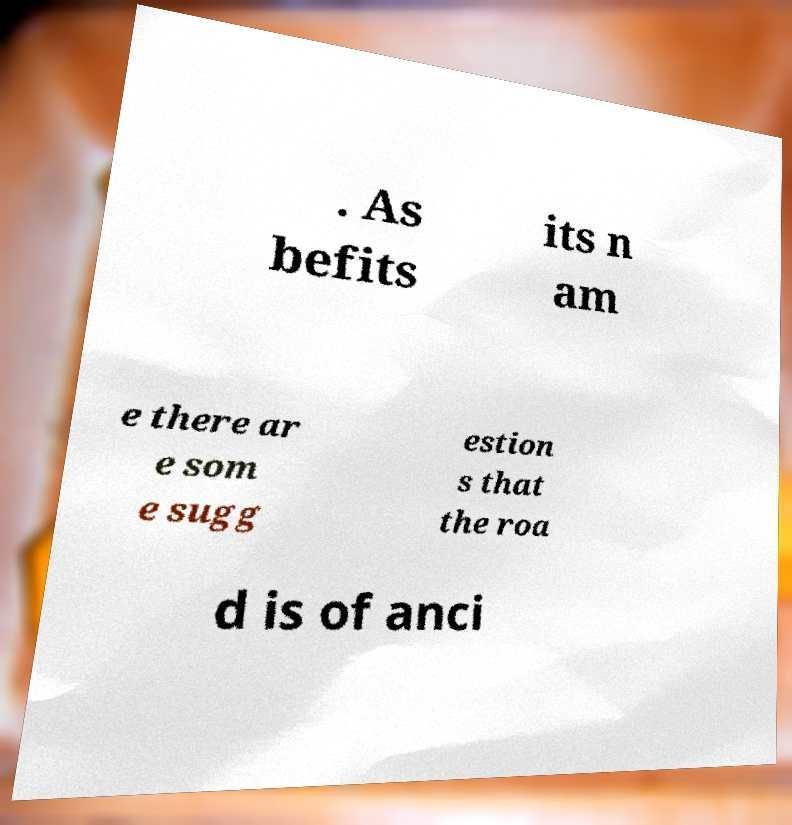For documentation purposes, I need the text within this image transcribed. Could you provide that? . As befits its n am e there ar e som e sugg estion s that the roa d is of anci 